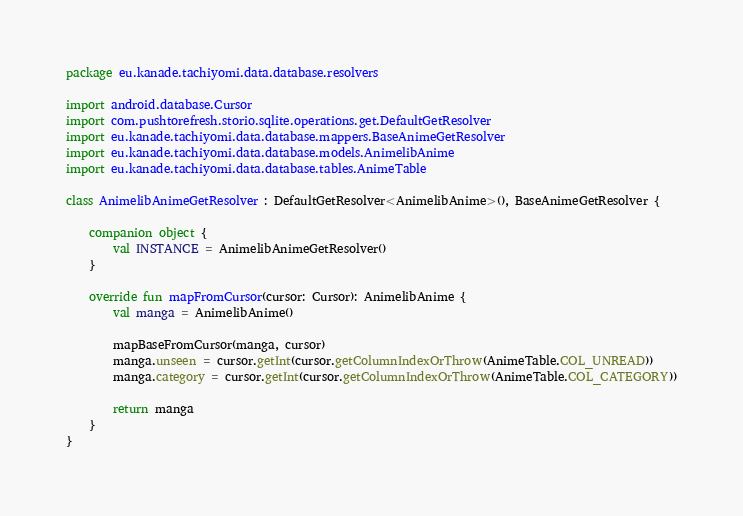<code> <loc_0><loc_0><loc_500><loc_500><_Kotlin_>package eu.kanade.tachiyomi.data.database.resolvers

import android.database.Cursor
import com.pushtorefresh.storio.sqlite.operations.get.DefaultGetResolver
import eu.kanade.tachiyomi.data.database.mappers.BaseAnimeGetResolver
import eu.kanade.tachiyomi.data.database.models.AnimelibAnime
import eu.kanade.tachiyomi.data.database.tables.AnimeTable

class AnimelibAnimeGetResolver : DefaultGetResolver<AnimelibAnime>(), BaseAnimeGetResolver {

    companion object {
        val INSTANCE = AnimelibAnimeGetResolver()
    }

    override fun mapFromCursor(cursor: Cursor): AnimelibAnime {
        val manga = AnimelibAnime()

        mapBaseFromCursor(manga, cursor)
        manga.unseen = cursor.getInt(cursor.getColumnIndexOrThrow(AnimeTable.COL_UNREAD))
        manga.category = cursor.getInt(cursor.getColumnIndexOrThrow(AnimeTable.COL_CATEGORY))

        return manga
    }
}
</code> 